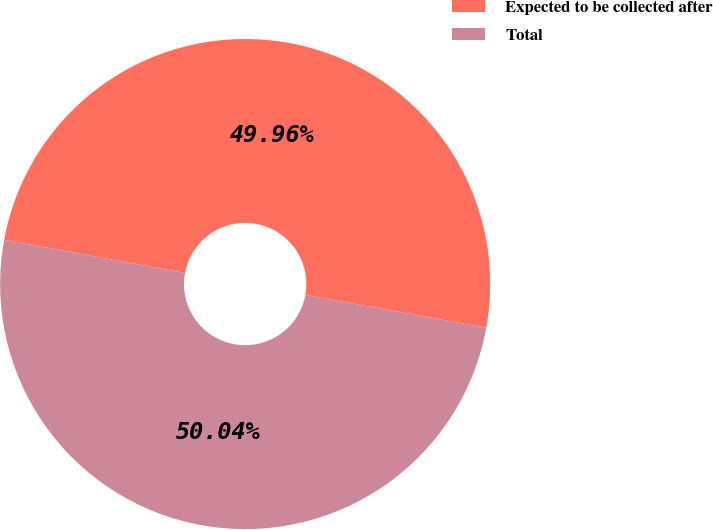Convert chart to OTSL. <chart><loc_0><loc_0><loc_500><loc_500><pie_chart><fcel>Expected to be collected after<fcel>Total<nl><fcel>49.96%<fcel>50.04%<nl></chart> 